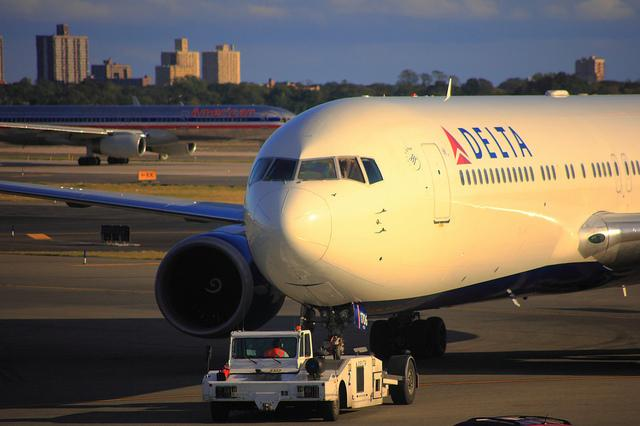What is the last letter of the name that appears on the plane? letter 